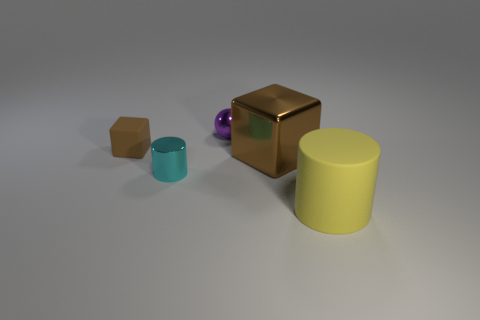Add 4 large metallic cylinders. How many objects exist? 9 Subtract all blocks. How many objects are left? 3 Add 2 small brown rubber cubes. How many small brown rubber cubes are left? 3 Add 1 metal cubes. How many metal cubes exist? 2 Subtract 0 green blocks. How many objects are left? 5 Subtract all tiny cyan cylinders. Subtract all balls. How many objects are left? 3 